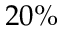<formula> <loc_0><loc_0><loc_500><loc_500>2 0 \%</formula> 